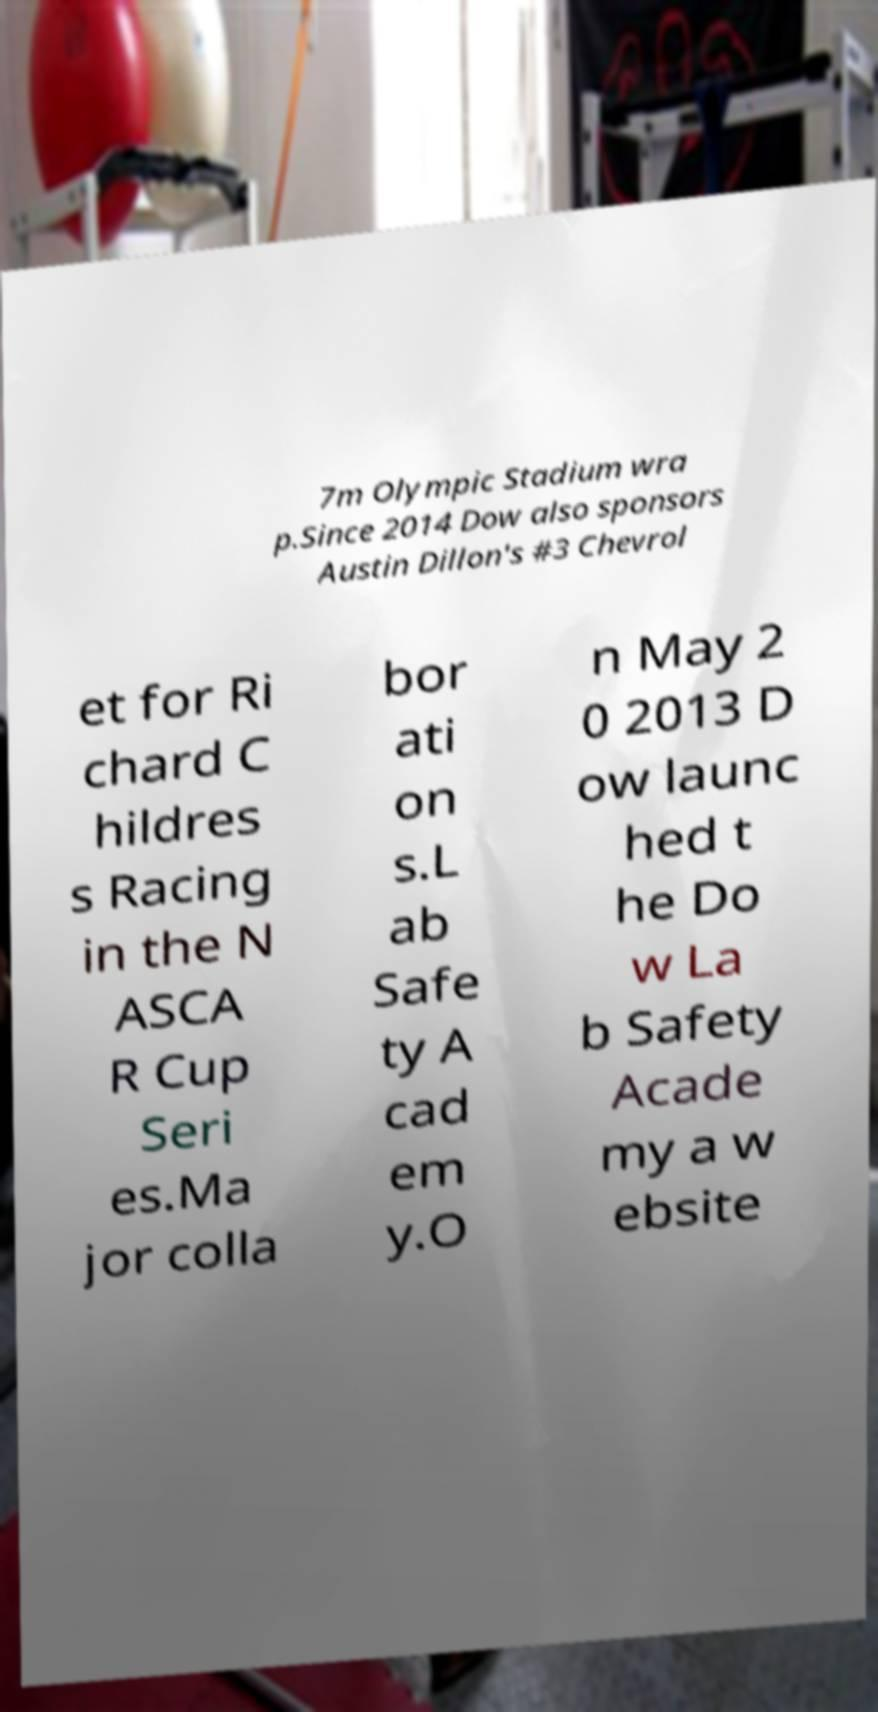There's text embedded in this image that I need extracted. Can you transcribe it verbatim? 7m Olympic Stadium wra p.Since 2014 Dow also sponsors Austin Dillon's #3 Chevrol et for Ri chard C hildres s Racing in the N ASCA R Cup Seri es.Ma jor colla bor ati on s.L ab Safe ty A cad em y.O n May 2 0 2013 D ow launc hed t he Do w La b Safety Acade my a w ebsite 